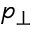Convert formula to latex. <formula><loc_0><loc_0><loc_500><loc_500>p _ { \bot }</formula> 